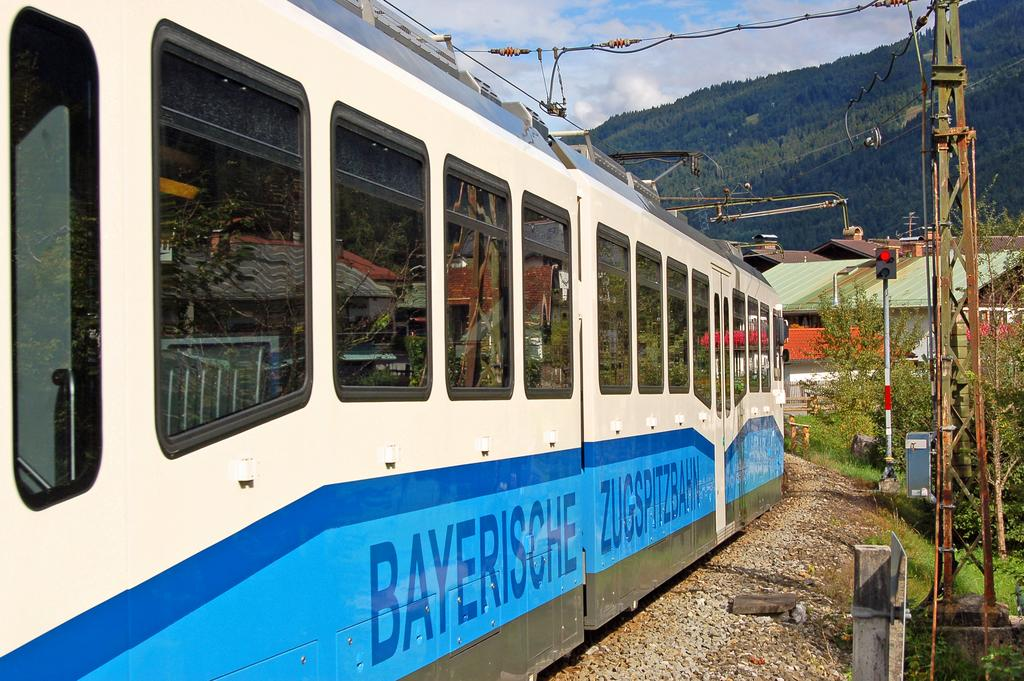<image>
Give a short and clear explanation of the subsequent image. A train says Bayerische on the side and has blue stripes on it. 